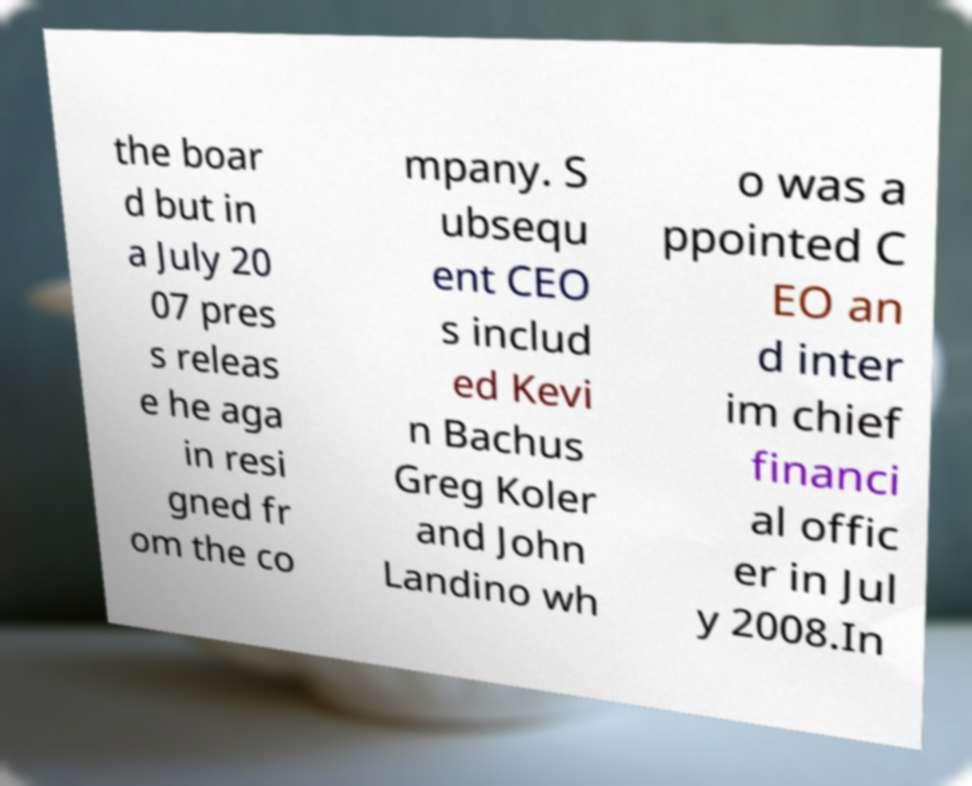What messages or text are displayed in this image? I need them in a readable, typed format. the boar d but in a July 20 07 pres s releas e he aga in resi gned fr om the co mpany. S ubsequ ent CEO s includ ed Kevi n Bachus Greg Koler and John Landino wh o was a ppointed C EO an d inter im chief financi al offic er in Jul y 2008.In 